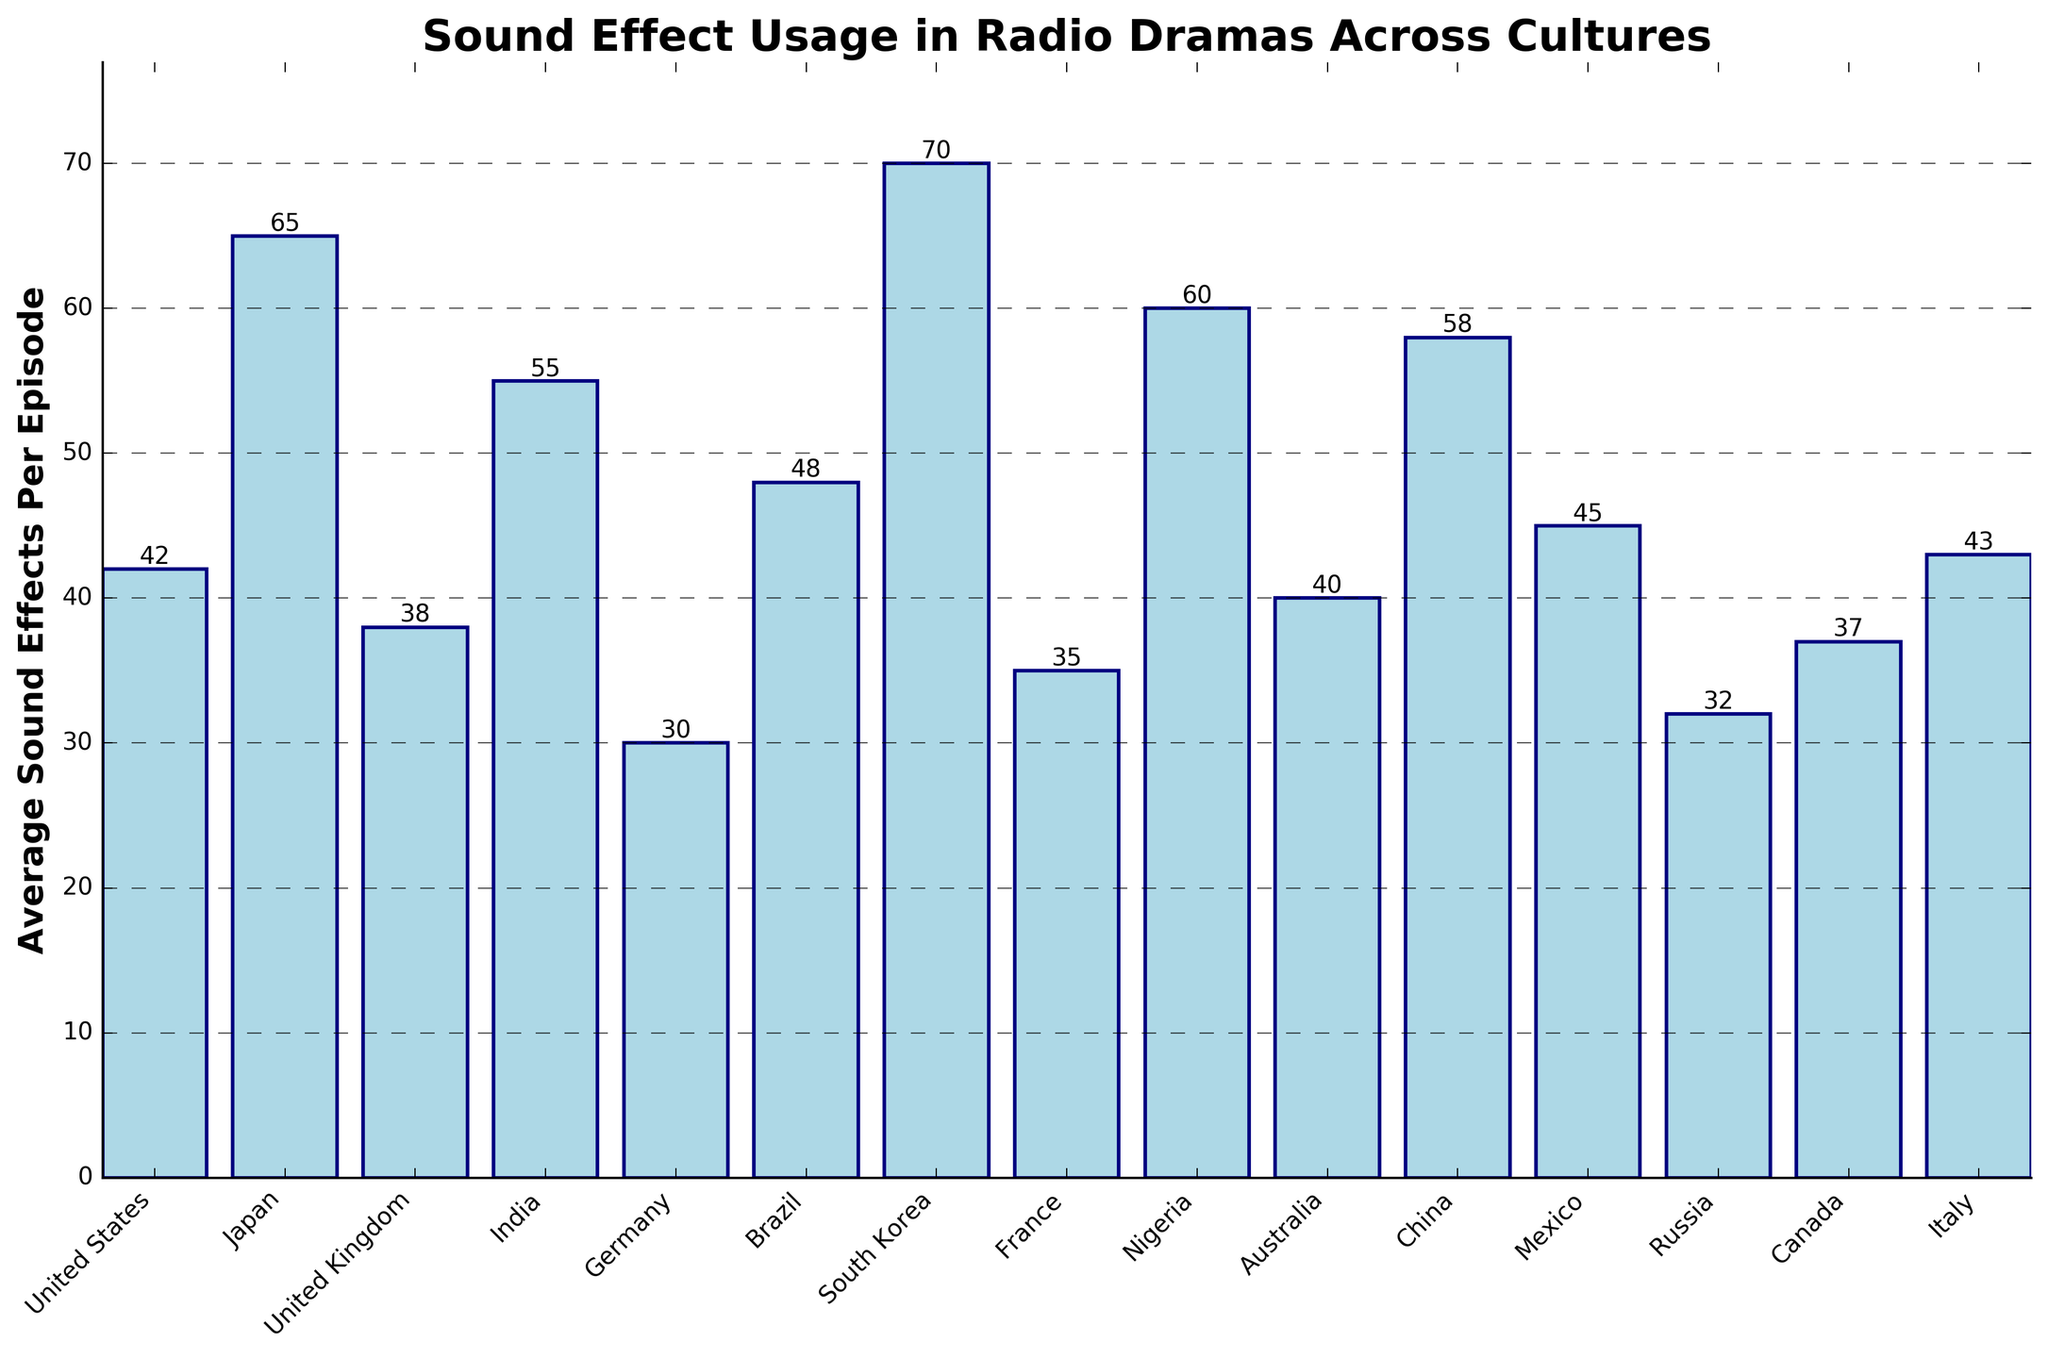Which culture has the highest average sound effects per episode? The chart shows the number of sound effects per episode for each culture. By identifying the tallest bar, we see that South Korea has the highest average with 70 sound effects.
Answer: South Korea Which culture has the lowest average sound effects per episode? The chart shows the number of sound effects per episode for each culture. By identifying the shortest bar, we see that Germany has the lowest average with 30 sound effects.
Answer: Germany How many more sound effects does Japan have compared to France? The chart shows that Japan has 65 sound effects and France has 35. The difference is calculated as 65 - 35.
Answer: 30 Which cultures have fewer than 40 average sound effects per episode? Looking at the bars in the chart, the cultures with bars lower than 40 are the United Kingdom, Germany, France, Russia, and Canada.
Answer: United Kingdom, Germany, France, Russia, Canada What is the average number of sound effects per episode for the United States, United Kingdom, and Australia? The chart shows the United States has 42, the United Kingdom has 38, and Australia has 40. Averaging these, (42 + 38 + 40) / 3 = 40.
Answer: 40 How many cultures have more than 50 average sound effects per episode? We identify the bars that are above the 50 mark: Japan, India, South Korea, Nigeria, China. There are 5 cultures in total.
Answer: 5 Is Mexico below or above the average number of sound effects per episode compared to other cultures? First, calculate the overall average. Sum all the values from the chart and divide by the number of cultures: (42+65+38+55+30+48+70+35+60+40+58+45+32+37+43) / 15 = 46.73. Mexico has 45, which is below the overall average.
Answer: Below What is the total number of sound effects per episode when combining Nigeria and Brazil? The chart shows Nigeria has 60 and Brazil has 48. Adding these together: 60 + 48 = 108.
Answer: 108 Does China have more sound effects per episode than Italy and Canada combined? China has 58 sound effects per episode. Italy and Canada combined have 43 + 37 = 80. Since 58 < 80, China has fewer sound effects.
Answer: No 